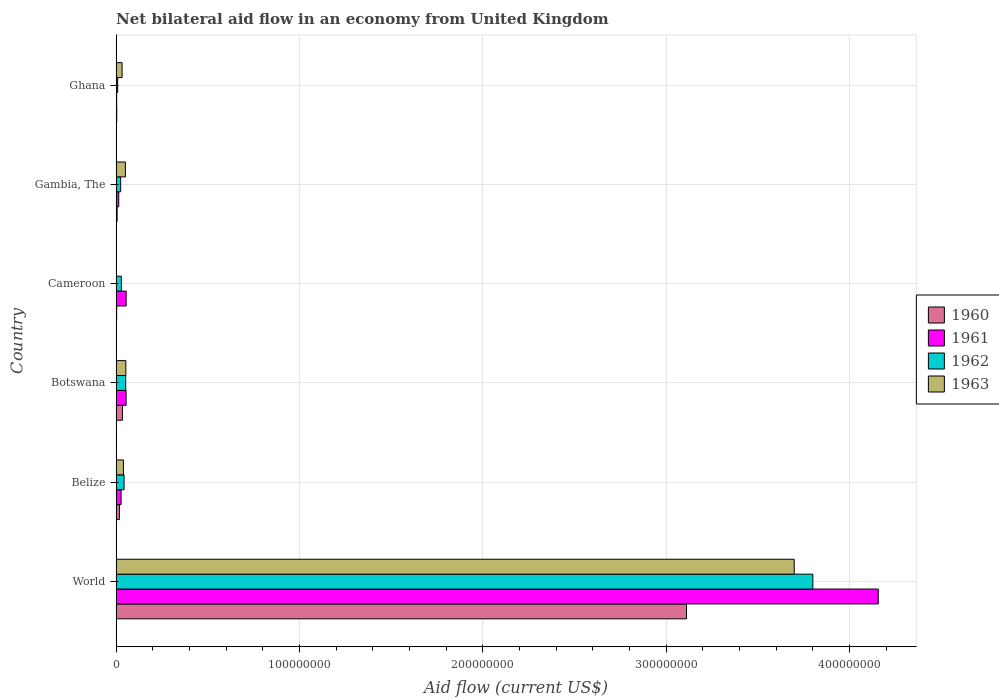How many different coloured bars are there?
Offer a very short reply. 4. How many groups of bars are there?
Your answer should be compact. 6. How many bars are there on the 2nd tick from the top?
Your answer should be very brief. 4. How many bars are there on the 3rd tick from the bottom?
Ensure brevity in your answer.  4. In how many cases, is the number of bars for a given country not equal to the number of legend labels?
Ensure brevity in your answer.  1. What is the net bilateral aid flow in 1963 in Belize?
Provide a short and direct response. 3.99e+06. Across all countries, what is the maximum net bilateral aid flow in 1963?
Your answer should be compact. 3.70e+08. What is the total net bilateral aid flow in 1962 in the graph?
Make the answer very short. 3.96e+08. What is the difference between the net bilateral aid flow in 1963 in Belize and that in Gambia, The?
Ensure brevity in your answer.  -1.07e+06. What is the difference between the net bilateral aid flow in 1962 in Ghana and the net bilateral aid flow in 1963 in World?
Give a very brief answer. -3.69e+08. What is the average net bilateral aid flow in 1962 per country?
Keep it short and to the point. 6.59e+07. What is the difference between the net bilateral aid flow in 1963 and net bilateral aid flow in 1960 in Belize?
Make the answer very short. 2.20e+06. In how many countries, is the net bilateral aid flow in 1962 greater than 220000000 US$?
Provide a succinct answer. 1. What is the ratio of the net bilateral aid flow in 1961 in Cameroon to that in World?
Ensure brevity in your answer.  0.01. Is the net bilateral aid flow in 1960 in Botswana less than that in Ghana?
Make the answer very short. No. Is the difference between the net bilateral aid flow in 1963 in Botswana and World greater than the difference between the net bilateral aid flow in 1960 in Botswana and World?
Ensure brevity in your answer.  No. What is the difference between the highest and the second highest net bilateral aid flow in 1961?
Provide a short and direct response. 4.10e+08. What is the difference between the highest and the lowest net bilateral aid flow in 1961?
Offer a very short reply. 4.15e+08. In how many countries, is the net bilateral aid flow in 1960 greater than the average net bilateral aid flow in 1960 taken over all countries?
Offer a very short reply. 1. Is it the case that in every country, the sum of the net bilateral aid flow in 1963 and net bilateral aid flow in 1961 is greater than the net bilateral aid flow in 1962?
Your answer should be compact. Yes. How many bars are there?
Offer a very short reply. 23. How many countries are there in the graph?
Your response must be concise. 6. Does the graph contain any zero values?
Your response must be concise. Yes. What is the title of the graph?
Give a very brief answer. Net bilateral aid flow in an economy from United Kingdom. Does "1978" appear as one of the legend labels in the graph?
Offer a very short reply. No. What is the label or title of the X-axis?
Your answer should be very brief. Aid flow (current US$). What is the Aid flow (current US$) in 1960 in World?
Offer a terse response. 3.11e+08. What is the Aid flow (current US$) in 1961 in World?
Ensure brevity in your answer.  4.16e+08. What is the Aid flow (current US$) of 1962 in World?
Your answer should be compact. 3.80e+08. What is the Aid flow (current US$) of 1963 in World?
Give a very brief answer. 3.70e+08. What is the Aid flow (current US$) of 1960 in Belize?
Ensure brevity in your answer.  1.79e+06. What is the Aid flow (current US$) of 1961 in Belize?
Ensure brevity in your answer.  2.70e+06. What is the Aid flow (current US$) of 1962 in Belize?
Make the answer very short. 4.33e+06. What is the Aid flow (current US$) of 1963 in Belize?
Make the answer very short. 3.99e+06. What is the Aid flow (current US$) of 1960 in Botswana?
Your answer should be compact. 3.43e+06. What is the Aid flow (current US$) of 1961 in Botswana?
Your response must be concise. 5.44e+06. What is the Aid flow (current US$) in 1962 in Botswana?
Ensure brevity in your answer.  5.22e+06. What is the Aid flow (current US$) in 1963 in Botswana?
Provide a short and direct response. 5.30e+06. What is the Aid flow (current US$) in 1960 in Cameroon?
Keep it short and to the point. 2.90e+05. What is the Aid flow (current US$) in 1961 in Cameroon?
Your response must be concise. 5.47e+06. What is the Aid flow (current US$) in 1962 in Cameroon?
Provide a succinct answer. 2.85e+06. What is the Aid flow (current US$) of 1963 in Cameroon?
Make the answer very short. 0. What is the Aid flow (current US$) in 1960 in Gambia, The?
Keep it short and to the point. 5.40e+05. What is the Aid flow (current US$) of 1961 in Gambia, The?
Make the answer very short. 1.43e+06. What is the Aid flow (current US$) in 1962 in Gambia, The?
Ensure brevity in your answer.  2.47e+06. What is the Aid flow (current US$) in 1963 in Gambia, The?
Keep it short and to the point. 5.06e+06. What is the Aid flow (current US$) of 1961 in Ghana?
Your answer should be very brief. 2.90e+05. What is the Aid flow (current US$) in 1962 in Ghana?
Make the answer very short. 8.30e+05. What is the Aid flow (current US$) in 1963 in Ghana?
Provide a short and direct response. 3.24e+06. Across all countries, what is the maximum Aid flow (current US$) in 1960?
Keep it short and to the point. 3.11e+08. Across all countries, what is the maximum Aid flow (current US$) in 1961?
Make the answer very short. 4.16e+08. Across all countries, what is the maximum Aid flow (current US$) of 1962?
Keep it short and to the point. 3.80e+08. Across all countries, what is the maximum Aid flow (current US$) of 1963?
Provide a succinct answer. 3.70e+08. Across all countries, what is the minimum Aid flow (current US$) in 1960?
Provide a short and direct response. 2.90e+05. Across all countries, what is the minimum Aid flow (current US$) of 1961?
Make the answer very short. 2.90e+05. Across all countries, what is the minimum Aid flow (current US$) in 1962?
Your answer should be very brief. 8.30e+05. Across all countries, what is the minimum Aid flow (current US$) of 1963?
Keep it short and to the point. 0. What is the total Aid flow (current US$) of 1960 in the graph?
Offer a terse response. 3.17e+08. What is the total Aid flow (current US$) of 1961 in the graph?
Make the answer very short. 4.31e+08. What is the total Aid flow (current US$) of 1962 in the graph?
Offer a very short reply. 3.96e+08. What is the total Aid flow (current US$) in 1963 in the graph?
Provide a short and direct response. 3.87e+08. What is the difference between the Aid flow (current US$) of 1960 in World and that in Belize?
Ensure brevity in your answer.  3.09e+08. What is the difference between the Aid flow (current US$) in 1961 in World and that in Belize?
Your answer should be compact. 4.13e+08. What is the difference between the Aid flow (current US$) in 1962 in World and that in Belize?
Give a very brief answer. 3.76e+08. What is the difference between the Aid flow (current US$) of 1963 in World and that in Belize?
Your answer should be compact. 3.66e+08. What is the difference between the Aid flow (current US$) in 1960 in World and that in Botswana?
Provide a short and direct response. 3.08e+08. What is the difference between the Aid flow (current US$) of 1961 in World and that in Botswana?
Provide a succinct answer. 4.10e+08. What is the difference between the Aid flow (current US$) in 1962 in World and that in Botswana?
Provide a short and direct response. 3.75e+08. What is the difference between the Aid flow (current US$) in 1963 in World and that in Botswana?
Provide a succinct answer. 3.65e+08. What is the difference between the Aid flow (current US$) of 1960 in World and that in Cameroon?
Offer a terse response. 3.11e+08. What is the difference between the Aid flow (current US$) in 1961 in World and that in Cameroon?
Provide a succinct answer. 4.10e+08. What is the difference between the Aid flow (current US$) of 1962 in World and that in Cameroon?
Ensure brevity in your answer.  3.77e+08. What is the difference between the Aid flow (current US$) in 1960 in World and that in Gambia, The?
Ensure brevity in your answer.  3.11e+08. What is the difference between the Aid flow (current US$) in 1961 in World and that in Gambia, The?
Your answer should be compact. 4.14e+08. What is the difference between the Aid flow (current US$) of 1962 in World and that in Gambia, The?
Offer a terse response. 3.78e+08. What is the difference between the Aid flow (current US$) in 1963 in World and that in Gambia, The?
Provide a succinct answer. 3.65e+08. What is the difference between the Aid flow (current US$) in 1960 in World and that in Ghana?
Your response must be concise. 3.11e+08. What is the difference between the Aid flow (current US$) of 1961 in World and that in Ghana?
Provide a short and direct response. 4.15e+08. What is the difference between the Aid flow (current US$) of 1962 in World and that in Ghana?
Your answer should be compact. 3.79e+08. What is the difference between the Aid flow (current US$) of 1963 in World and that in Ghana?
Your response must be concise. 3.67e+08. What is the difference between the Aid flow (current US$) of 1960 in Belize and that in Botswana?
Offer a terse response. -1.64e+06. What is the difference between the Aid flow (current US$) in 1961 in Belize and that in Botswana?
Your answer should be compact. -2.74e+06. What is the difference between the Aid flow (current US$) in 1962 in Belize and that in Botswana?
Ensure brevity in your answer.  -8.90e+05. What is the difference between the Aid flow (current US$) of 1963 in Belize and that in Botswana?
Make the answer very short. -1.31e+06. What is the difference between the Aid flow (current US$) in 1960 in Belize and that in Cameroon?
Make the answer very short. 1.50e+06. What is the difference between the Aid flow (current US$) of 1961 in Belize and that in Cameroon?
Your answer should be very brief. -2.77e+06. What is the difference between the Aid flow (current US$) of 1962 in Belize and that in Cameroon?
Keep it short and to the point. 1.48e+06. What is the difference between the Aid flow (current US$) in 1960 in Belize and that in Gambia, The?
Provide a succinct answer. 1.25e+06. What is the difference between the Aid flow (current US$) of 1961 in Belize and that in Gambia, The?
Offer a terse response. 1.27e+06. What is the difference between the Aid flow (current US$) in 1962 in Belize and that in Gambia, The?
Your response must be concise. 1.86e+06. What is the difference between the Aid flow (current US$) of 1963 in Belize and that in Gambia, The?
Make the answer very short. -1.07e+06. What is the difference between the Aid flow (current US$) in 1960 in Belize and that in Ghana?
Provide a short and direct response. 1.45e+06. What is the difference between the Aid flow (current US$) in 1961 in Belize and that in Ghana?
Make the answer very short. 2.41e+06. What is the difference between the Aid flow (current US$) of 1962 in Belize and that in Ghana?
Your answer should be very brief. 3.50e+06. What is the difference between the Aid flow (current US$) of 1963 in Belize and that in Ghana?
Offer a terse response. 7.50e+05. What is the difference between the Aid flow (current US$) in 1960 in Botswana and that in Cameroon?
Your response must be concise. 3.14e+06. What is the difference between the Aid flow (current US$) in 1962 in Botswana and that in Cameroon?
Your answer should be very brief. 2.37e+06. What is the difference between the Aid flow (current US$) of 1960 in Botswana and that in Gambia, The?
Your answer should be compact. 2.89e+06. What is the difference between the Aid flow (current US$) of 1961 in Botswana and that in Gambia, The?
Provide a succinct answer. 4.01e+06. What is the difference between the Aid flow (current US$) in 1962 in Botswana and that in Gambia, The?
Offer a very short reply. 2.75e+06. What is the difference between the Aid flow (current US$) in 1963 in Botswana and that in Gambia, The?
Ensure brevity in your answer.  2.40e+05. What is the difference between the Aid flow (current US$) in 1960 in Botswana and that in Ghana?
Offer a terse response. 3.09e+06. What is the difference between the Aid flow (current US$) of 1961 in Botswana and that in Ghana?
Provide a short and direct response. 5.15e+06. What is the difference between the Aid flow (current US$) in 1962 in Botswana and that in Ghana?
Your answer should be very brief. 4.39e+06. What is the difference between the Aid flow (current US$) of 1963 in Botswana and that in Ghana?
Keep it short and to the point. 2.06e+06. What is the difference between the Aid flow (current US$) of 1960 in Cameroon and that in Gambia, The?
Make the answer very short. -2.50e+05. What is the difference between the Aid flow (current US$) in 1961 in Cameroon and that in Gambia, The?
Provide a short and direct response. 4.04e+06. What is the difference between the Aid flow (current US$) of 1961 in Cameroon and that in Ghana?
Your answer should be compact. 5.18e+06. What is the difference between the Aid flow (current US$) of 1962 in Cameroon and that in Ghana?
Give a very brief answer. 2.02e+06. What is the difference between the Aid flow (current US$) in 1960 in Gambia, The and that in Ghana?
Give a very brief answer. 2.00e+05. What is the difference between the Aid flow (current US$) of 1961 in Gambia, The and that in Ghana?
Provide a short and direct response. 1.14e+06. What is the difference between the Aid flow (current US$) in 1962 in Gambia, The and that in Ghana?
Provide a succinct answer. 1.64e+06. What is the difference between the Aid flow (current US$) in 1963 in Gambia, The and that in Ghana?
Provide a short and direct response. 1.82e+06. What is the difference between the Aid flow (current US$) of 1960 in World and the Aid flow (current US$) of 1961 in Belize?
Offer a very short reply. 3.08e+08. What is the difference between the Aid flow (current US$) of 1960 in World and the Aid flow (current US$) of 1962 in Belize?
Offer a very short reply. 3.07e+08. What is the difference between the Aid flow (current US$) in 1960 in World and the Aid flow (current US$) in 1963 in Belize?
Your response must be concise. 3.07e+08. What is the difference between the Aid flow (current US$) in 1961 in World and the Aid flow (current US$) in 1962 in Belize?
Offer a terse response. 4.11e+08. What is the difference between the Aid flow (current US$) in 1961 in World and the Aid flow (current US$) in 1963 in Belize?
Offer a terse response. 4.12e+08. What is the difference between the Aid flow (current US$) of 1962 in World and the Aid flow (current US$) of 1963 in Belize?
Provide a succinct answer. 3.76e+08. What is the difference between the Aid flow (current US$) in 1960 in World and the Aid flow (current US$) in 1961 in Botswana?
Give a very brief answer. 3.06e+08. What is the difference between the Aid flow (current US$) of 1960 in World and the Aid flow (current US$) of 1962 in Botswana?
Make the answer very short. 3.06e+08. What is the difference between the Aid flow (current US$) in 1960 in World and the Aid flow (current US$) in 1963 in Botswana?
Keep it short and to the point. 3.06e+08. What is the difference between the Aid flow (current US$) in 1961 in World and the Aid flow (current US$) in 1962 in Botswana?
Keep it short and to the point. 4.10e+08. What is the difference between the Aid flow (current US$) of 1961 in World and the Aid flow (current US$) of 1963 in Botswana?
Make the answer very short. 4.10e+08. What is the difference between the Aid flow (current US$) of 1962 in World and the Aid flow (current US$) of 1963 in Botswana?
Your answer should be compact. 3.75e+08. What is the difference between the Aid flow (current US$) in 1960 in World and the Aid flow (current US$) in 1961 in Cameroon?
Give a very brief answer. 3.06e+08. What is the difference between the Aid flow (current US$) of 1960 in World and the Aid flow (current US$) of 1962 in Cameroon?
Ensure brevity in your answer.  3.08e+08. What is the difference between the Aid flow (current US$) of 1961 in World and the Aid flow (current US$) of 1962 in Cameroon?
Give a very brief answer. 4.13e+08. What is the difference between the Aid flow (current US$) in 1960 in World and the Aid flow (current US$) in 1961 in Gambia, The?
Provide a succinct answer. 3.10e+08. What is the difference between the Aid flow (current US$) in 1960 in World and the Aid flow (current US$) in 1962 in Gambia, The?
Make the answer very short. 3.09e+08. What is the difference between the Aid flow (current US$) of 1960 in World and the Aid flow (current US$) of 1963 in Gambia, The?
Ensure brevity in your answer.  3.06e+08. What is the difference between the Aid flow (current US$) of 1961 in World and the Aid flow (current US$) of 1962 in Gambia, The?
Offer a terse response. 4.13e+08. What is the difference between the Aid flow (current US$) of 1961 in World and the Aid flow (current US$) of 1963 in Gambia, The?
Your response must be concise. 4.11e+08. What is the difference between the Aid flow (current US$) in 1962 in World and the Aid flow (current US$) in 1963 in Gambia, The?
Give a very brief answer. 3.75e+08. What is the difference between the Aid flow (current US$) of 1960 in World and the Aid flow (current US$) of 1961 in Ghana?
Make the answer very short. 3.11e+08. What is the difference between the Aid flow (current US$) in 1960 in World and the Aid flow (current US$) in 1962 in Ghana?
Ensure brevity in your answer.  3.10e+08. What is the difference between the Aid flow (current US$) of 1960 in World and the Aid flow (current US$) of 1963 in Ghana?
Keep it short and to the point. 3.08e+08. What is the difference between the Aid flow (current US$) in 1961 in World and the Aid flow (current US$) in 1962 in Ghana?
Ensure brevity in your answer.  4.15e+08. What is the difference between the Aid flow (current US$) of 1961 in World and the Aid flow (current US$) of 1963 in Ghana?
Offer a terse response. 4.12e+08. What is the difference between the Aid flow (current US$) in 1962 in World and the Aid flow (current US$) in 1963 in Ghana?
Your answer should be very brief. 3.77e+08. What is the difference between the Aid flow (current US$) of 1960 in Belize and the Aid flow (current US$) of 1961 in Botswana?
Your answer should be very brief. -3.65e+06. What is the difference between the Aid flow (current US$) in 1960 in Belize and the Aid flow (current US$) in 1962 in Botswana?
Provide a short and direct response. -3.43e+06. What is the difference between the Aid flow (current US$) in 1960 in Belize and the Aid flow (current US$) in 1963 in Botswana?
Your answer should be very brief. -3.51e+06. What is the difference between the Aid flow (current US$) of 1961 in Belize and the Aid flow (current US$) of 1962 in Botswana?
Provide a succinct answer. -2.52e+06. What is the difference between the Aid flow (current US$) of 1961 in Belize and the Aid flow (current US$) of 1963 in Botswana?
Provide a short and direct response. -2.60e+06. What is the difference between the Aid flow (current US$) in 1962 in Belize and the Aid flow (current US$) in 1963 in Botswana?
Offer a terse response. -9.70e+05. What is the difference between the Aid flow (current US$) of 1960 in Belize and the Aid flow (current US$) of 1961 in Cameroon?
Give a very brief answer. -3.68e+06. What is the difference between the Aid flow (current US$) of 1960 in Belize and the Aid flow (current US$) of 1962 in Cameroon?
Your answer should be compact. -1.06e+06. What is the difference between the Aid flow (current US$) in 1961 in Belize and the Aid flow (current US$) in 1962 in Cameroon?
Keep it short and to the point. -1.50e+05. What is the difference between the Aid flow (current US$) in 1960 in Belize and the Aid flow (current US$) in 1962 in Gambia, The?
Your answer should be compact. -6.80e+05. What is the difference between the Aid flow (current US$) in 1960 in Belize and the Aid flow (current US$) in 1963 in Gambia, The?
Provide a succinct answer. -3.27e+06. What is the difference between the Aid flow (current US$) of 1961 in Belize and the Aid flow (current US$) of 1962 in Gambia, The?
Keep it short and to the point. 2.30e+05. What is the difference between the Aid flow (current US$) in 1961 in Belize and the Aid flow (current US$) in 1963 in Gambia, The?
Provide a succinct answer. -2.36e+06. What is the difference between the Aid flow (current US$) of 1962 in Belize and the Aid flow (current US$) of 1963 in Gambia, The?
Ensure brevity in your answer.  -7.30e+05. What is the difference between the Aid flow (current US$) in 1960 in Belize and the Aid flow (current US$) in 1961 in Ghana?
Your answer should be very brief. 1.50e+06. What is the difference between the Aid flow (current US$) of 1960 in Belize and the Aid flow (current US$) of 1962 in Ghana?
Make the answer very short. 9.60e+05. What is the difference between the Aid flow (current US$) in 1960 in Belize and the Aid flow (current US$) in 1963 in Ghana?
Give a very brief answer. -1.45e+06. What is the difference between the Aid flow (current US$) of 1961 in Belize and the Aid flow (current US$) of 1962 in Ghana?
Ensure brevity in your answer.  1.87e+06. What is the difference between the Aid flow (current US$) in 1961 in Belize and the Aid flow (current US$) in 1963 in Ghana?
Make the answer very short. -5.40e+05. What is the difference between the Aid flow (current US$) of 1962 in Belize and the Aid flow (current US$) of 1963 in Ghana?
Make the answer very short. 1.09e+06. What is the difference between the Aid flow (current US$) in 1960 in Botswana and the Aid flow (current US$) in 1961 in Cameroon?
Your answer should be compact. -2.04e+06. What is the difference between the Aid flow (current US$) of 1960 in Botswana and the Aid flow (current US$) of 1962 in Cameroon?
Provide a short and direct response. 5.80e+05. What is the difference between the Aid flow (current US$) in 1961 in Botswana and the Aid flow (current US$) in 1962 in Cameroon?
Your response must be concise. 2.59e+06. What is the difference between the Aid flow (current US$) in 1960 in Botswana and the Aid flow (current US$) in 1961 in Gambia, The?
Make the answer very short. 2.00e+06. What is the difference between the Aid flow (current US$) in 1960 in Botswana and the Aid flow (current US$) in 1962 in Gambia, The?
Give a very brief answer. 9.60e+05. What is the difference between the Aid flow (current US$) of 1960 in Botswana and the Aid flow (current US$) of 1963 in Gambia, The?
Your answer should be compact. -1.63e+06. What is the difference between the Aid flow (current US$) in 1961 in Botswana and the Aid flow (current US$) in 1962 in Gambia, The?
Make the answer very short. 2.97e+06. What is the difference between the Aid flow (current US$) of 1960 in Botswana and the Aid flow (current US$) of 1961 in Ghana?
Your response must be concise. 3.14e+06. What is the difference between the Aid flow (current US$) in 1960 in Botswana and the Aid flow (current US$) in 1962 in Ghana?
Provide a succinct answer. 2.60e+06. What is the difference between the Aid flow (current US$) in 1960 in Botswana and the Aid flow (current US$) in 1963 in Ghana?
Keep it short and to the point. 1.90e+05. What is the difference between the Aid flow (current US$) in 1961 in Botswana and the Aid flow (current US$) in 1962 in Ghana?
Offer a terse response. 4.61e+06. What is the difference between the Aid flow (current US$) in 1961 in Botswana and the Aid flow (current US$) in 1963 in Ghana?
Offer a terse response. 2.20e+06. What is the difference between the Aid flow (current US$) in 1962 in Botswana and the Aid flow (current US$) in 1963 in Ghana?
Give a very brief answer. 1.98e+06. What is the difference between the Aid flow (current US$) of 1960 in Cameroon and the Aid flow (current US$) of 1961 in Gambia, The?
Ensure brevity in your answer.  -1.14e+06. What is the difference between the Aid flow (current US$) in 1960 in Cameroon and the Aid flow (current US$) in 1962 in Gambia, The?
Ensure brevity in your answer.  -2.18e+06. What is the difference between the Aid flow (current US$) of 1960 in Cameroon and the Aid flow (current US$) of 1963 in Gambia, The?
Keep it short and to the point. -4.77e+06. What is the difference between the Aid flow (current US$) of 1961 in Cameroon and the Aid flow (current US$) of 1963 in Gambia, The?
Your response must be concise. 4.10e+05. What is the difference between the Aid flow (current US$) in 1962 in Cameroon and the Aid flow (current US$) in 1963 in Gambia, The?
Your answer should be compact. -2.21e+06. What is the difference between the Aid flow (current US$) in 1960 in Cameroon and the Aid flow (current US$) in 1962 in Ghana?
Ensure brevity in your answer.  -5.40e+05. What is the difference between the Aid flow (current US$) of 1960 in Cameroon and the Aid flow (current US$) of 1963 in Ghana?
Offer a terse response. -2.95e+06. What is the difference between the Aid flow (current US$) in 1961 in Cameroon and the Aid flow (current US$) in 1962 in Ghana?
Keep it short and to the point. 4.64e+06. What is the difference between the Aid flow (current US$) of 1961 in Cameroon and the Aid flow (current US$) of 1963 in Ghana?
Provide a short and direct response. 2.23e+06. What is the difference between the Aid flow (current US$) in 1962 in Cameroon and the Aid flow (current US$) in 1963 in Ghana?
Provide a succinct answer. -3.90e+05. What is the difference between the Aid flow (current US$) of 1960 in Gambia, The and the Aid flow (current US$) of 1962 in Ghana?
Make the answer very short. -2.90e+05. What is the difference between the Aid flow (current US$) of 1960 in Gambia, The and the Aid flow (current US$) of 1963 in Ghana?
Ensure brevity in your answer.  -2.70e+06. What is the difference between the Aid flow (current US$) in 1961 in Gambia, The and the Aid flow (current US$) in 1963 in Ghana?
Give a very brief answer. -1.81e+06. What is the difference between the Aid flow (current US$) in 1962 in Gambia, The and the Aid flow (current US$) in 1963 in Ghana?
Keep it short and to the point. -7.70e+05. What is the average Aid flow (current US$) in 1960 per country?
Provide a succinct answer. 5.29e+07. What is the average Aid flow (current US$) of 1961 per country?
Keep it short and to the point. 7.18e+07. What is the average Aid flow (current US$) in 1962 per country?
Your answer should be compact. 6.59e+07. What is the average Aid flow (current US$) of 1963 per country?
Offer a very short reply. 6.46e+07. What is the difference between the Aid flow (current US$) of 1960 and Aid flow (current US$) of 1961 in World?
Your response must be concise. -1.05e+08. What is the difference between the Aid flow (current US$) in 1960 and Aid flow (current US$) in 1962 in World?
Provide a short and direct response. -6.89e+07. What is the difference between the Aid flow (current US$) in 1960 and Aid flow (current US$) in 1963 in World?
Your answer should be very brief. -5.88e+07. What is the difference between the Aid flow (current US$) of 1961 and Aid flow (current US$) of 1962 in World?
Your answer should be very brief. 3.57e+07. What is the difference between the Aid flow (current US$) in 1961 and Aid flow (current US$) in 1963 in World?
Offer a very short reply. 4.58e+07. What is the difference between the Aid flow (current US$) in 1962 and Aid flow (current US$) in 1963 in World?
Provide a short and direct response. 1.02e+07. What is the difference between the Aid flow (current US$) of 1960 and Aid flow (current US$) of 1961 in Belize?
Your answer should be very brief. -9.10e+05. What is the difference between the Aid flow (current US$) in 1960 and Aid flow (current US$) in 1962 in Belize?
Your response must be concise. -2.54e+06. What is the difference between the Aid flow (current US$) in 1960 and Aid flow (current US$) in 1963 in Belize?
Make the answer very short. -2.20e+06. What is the difference between the Aid flow (current US$) of 1961 and Aid flow (current US$) of 1962 in Belize?
Ensure brevity in your answer.  -1.63e+06. What is the difference between the Aid flow (current US$) of 1961 and Aid flow (current US$) of 1963 in Belize?
Give a very brief answer. -1.29e+06. What is the difference between the Aid flow (current US$) of 1962 and Aid flow (current US$) of 1963 in Belize?
Your response must be concise. 3.40e+05. What is the difference between the Aid flow (current US$) in 1960 and Aid flow (current US$) in 1961 in Botswana?
Give a very brief answer. -2.01e+06. What is the difference between the Aid flow (current US$) of 1960 and Aid flow (current US$) of 1962 in Botswana?
Offer a very short reply. -1.79e+06. What is the difference between the Aid flow (current US$) of 1960 and Aid flow (current US$) of 1963 in Botswana?
Your answer should be very brief. -1.87e+06. What is the difference between the Aid flow (current US$) of 1961 and Aid flow (current US$) of 1962 in Botswana?
Your response must be concise. 2.20e+05. What is the difference between the Aid flow (current US$) in 1960 and Aid flow (current US$) in 1961 in Cameroon?
Offer a terse response. -5.18e+06. What is the difference between the Aid flow (current US$) in 1960 and Aid flow (current US$) in 1962 in Cameroon?
Ensure brevity in your answer.  -2.56e+06. What is the difference between the Aid flow (current US$) of 1961 and Aid flow (current US$) of 1962 in Cameroon?
Offer a terse response. 2.62e+06. What is the difference between the Aid flow (current US$) in 1960 and Aid flow (current US$) in 1961 in Gambia, The?
Offer a terse response. -8.90e+05. What is the difference between the Aid flow (current US$) of 1960 and Aid flow (current US$) of 1962 in Gambia, The?
Provide a succinct answer. -1.93e+06. What is the difference between the Aid flow (current US$) in 1960 and Aid flow (current US$) in 1963 in Gambia, The?
Offer a very short reply. -4.52e+06. What is the difference between the Aid flow (current US$) in 1961 and Aid flow (current US$) in 1962 in Gambia, The?
Give a very brief answer. -1.04e+06. What is the difference between the Aid flow (current US$) of 1961 and Aid flow (current US$) of 1963 in Gambia, The?
Give a very brief answer. -3.63e+06. What is the difference between the Aid flow (current US$) in 1962 and Aid flow (current US$) in 1963 in Gambia, The?
Ensure brevity in your answer.  -2.59e+06. What is the difference between the Aid flow (current US$) of 1960 and Aid flow (current US$) of 1961 in Ghana?
Your answer should be compact. 5.00e+04. What is the difference between the Aid flow (current US$) in 1960 and Aid flow (current US$) in 1962 in Ghana?
Your answer should be very brief. -4.90e+05. What is the difference between the Aid flow (current US$) of 1960 and Aid flow (current US$) of 1963 in Ghana?
Make the answer very short. -2.90e+06. What is the difference between the Aid flow (current US$) in 1961 and Aid flow (current US$) in 1962 in Ghana?
Offer a terse response. -5.40e+05. What is the difference between the Aid flow (current US$) of 1961 and Aid flow (current US$) of 1963 in Ghana?
Keep it short and to the point. -2.95e+06. What is the difference between the Aid flow (current US$) of 1962 and Aid flow (current US$) of 1963 in Ghana?
Give a very brief answer. -2.41e+06. What is the ratio of the Aid flow (current US$) of 1960 in World to that in Belize?
Give a very brief answer. 173.77. What is the ratio of the Aid flow (current US$) of 1961 in World to that in Belize?
Offer a terse response. 153.94. What is the ratio of the Aid flow (current US$) in 1962 in World to that in Belize?
Provide a short and direct response. 87.75. What is the ratio of the Aid flow (current US$) of 1963 in World to that in Belize?
Your response must be concise. 92.68. What is the ratio of the Aid flow (current US$) in 1960 in World to that in Botswana?
Your answer should be compact. 90.69. What is the ratio of the Aid flow (current US$) of 1961 in World to that in Botswana?
Provide a succinct answer. 76.4. What is the ratio of the Aid flow (current US$) in 1962 in World to that in Botswana?
Provide a short and direct response. 72.79. What is the ratio of the Aid flow (current US$) in 1963 in World to that in Botswana?
Provide a short and direct response. 69.78. What is the ratio of the Aid flow (current US$) in 1960 in World to that in Cameroon?
Ensure brevity in your answer.  1072.59. What is the ratio of the Aid flow (current US$) in 1961 in World to that in Cameroon?
Your answer should be very brief. 75.99. What is the ratio of the Aid flow (current US$) in 1962 in World to that in Cameroon?
Provide a succinct answer. 133.32. What is the ratio of the Aid flow (current US$) of 1960 in World to that in Gambia, The?
Offer a very short reply. 576.02. What is the ratio of the Aid flow (current US$) of 1961 in World to that in Gambia, The?
Make the answer very short. 290.66. What is the ratio of the Aid flow (current US$) of 1962 in World to that in Gambia, The?
Offer a terse response. 153.83. What is the ratio of the Aid flow (current US$) of 1963 in World to that in Gambia, The?
Keep it short and to the point. 73.08. What is the ratio of the Aid flow (current US$) in 1960 in World to that in Ghana?
Offer a very short reply. 914.85. What is the ratio of the Aid flow (current US$) of 1961 in World to that in Ghana?
Offer a very short reply. 1433.24. What is the ratio of the Aid flow (current US$) in 1962 in World to that in Ghana?
Offer a very short reply. 457.8. What is the ratio of the Aid flow (current US$) in 1963 in World to that in Ghana?
Offer a very short reply. 114.14. What is the ratio of the Aid flow (current US$) of 1960 in Belize to that in Botswana?
Your answer should be compact. 0.52. What is the ratio of the Aid flow (current US$) of 1961 in Belize to that in Botswana?
Keep it short and to the point. 0.5. What is the ratio of the Aid flow (current US$) in 1962 in Belize to that in Botswana?
Give a very brief answer. 0.83. What is the ratio of the Aid flow (current US$) in 1963 in Belize to that in Botswana?
Make the answer very short. 0.75. What is the ratio of the Aid flow (current US$) in 1960 in Belize to that in Cameroon?
Keep it short and to the point. 6.17. What is the ratio of the Aid flow (current US$) in 1961 in Belize to that in Cameroon?
Provide a succinct answer. 0.49. What is the ratio of the Aid flow (current US$) in 1962 in Belize to that in Cameroon?
Ensure brevity in your answer.  1.52. What is the ratio of the Aid flow (current US$) in 1960 in Belize to that in Gambia, The?
Offer a terse response. 3.31. What is the ratio of the Aid flow (current US$) in 1961 in Belize to that in Gambia, The?
Offer a very short reply. 1.89. What is the ratio of the Aid flow (current US$) in 1962 in Belize to that in Gambia, The?
Provide a short and direct response. 1.75. What is the ratio of the Aid flow (current US$) in 1963 in Belize to that in Gambia, The?
Ensure brevity in your answer.  0.79. What is the ratio of the Aid flow (current US$) in 1960 in Belize to that in Ghana?
Your answer should be compact. 5.26. What is the ratio of the Aid flow (current US$) of 1961 in Belize to that in Ghana?
Keep it short and to the point. 9.31. What is the ratio of the Aid flow (current US$) in 1962 in Belize to that in Ghana?
Give a very brief answer. 5.22. What is the ratio of the Aid flow (current US$) of 1963 in Belize to that in Ghana?
Your answer should be very brief. 1.23. What is the ratio of the Aid flow (current US$) in 1960 in Botswana to that in Cameroon?
Your answer should be very brief. 11.83. What is the ratio of the Aid flow (current US$) of 1961 in Botswana to that in Cameroon?
Make the answer very short. 0.99. What is the ratio of the Aid flow (current US$) in 1962 in Botswana to that in Cameroon?
Provide a succinct answer. 1.83. What is the ratio of the Aid flow (current US$) in 1960 in Botswana to that in Gambia, The?
Offer a very short reply. 6.35. What is the ratio of the Aid flow (current US$) in 1961 in Botswana to that in Gambia, The?
Provide a short and direct response. 3.8. What is the ratio of the Aid flow (current US$) of 1962 in Botswana to that in Gambia, The?
Keep it short and to the point. 2.11. What is the ratio of the Aid flow (current US$) of 1963 in Botswana to that in Gambia, The?
Your answer should be compact. 1.05. What is the ratio of the Aid flow (current US$) in 1960 in Botswana to that in Ghana?
Your response must be concise. 10.09. What is the ratio of the Aid flow (current US$) in 1961 in Botswana to that in Ghana?
Provide a short and direct response. 18.76. What is the ratio of the Aid flow (current US$) of 1962 in Botswana to that in Ghana?
Provide a short and direct response. 6.29. What is the ratio of the Aid flow (current US$) of 1963 in Botswana to that in Ghana?
Keep it short and to the point. 1.64. What is the ratio of the Aid flow (current US$) in 1960 in Cameroon to that in Gambia, The?
Offer a very short reply. 0.54. What is the ratio of the Aid flow (current US$) of 1961 in Cameroon to that in Gambia, The?
Offer a very short reply. 3.83. What is the ratio of the Aid flow (current US$) in 1962 in Cameroon to that in Gambia, The?
Your response must be concise. 1.15. What is the ratio of the Aid flow (current US$) in 1960 in Cameroon to that in Ghana?
Make the answer very short. 0.85. What is the ratio of the Aid flow (current US$) of 1961 in Cameroon to that in Ghana?
Provide a short and direct response. 18.86. What is the ratio of the Aid flow (current US$) in 1962 in Cameroon to that in Ghana?
Ensure brevity in your answer.  3.43. What is the ratio of the Aid flow (current US$) of 1960 in Gambia, The to that in Ghana?
Provide a succinct answer. 1.59. What is the ratio of the Aid flow (current US$) of 1961 in Gambia, The to that in Ghana?
Make the answer very short. 4.93. What is the ratio of the Aid flow (current US$) in 1962 in Gambia, The to that in Ghana?
Keep it short and to the point. 2.98. What is the ratio of the Aid flow (current US$) in 1963 in Gambia, The to that in Ghana?
Provide a short and direct response. 1.56. What is the difference between the highest and the second highest Aid flow (current US$) of 1960?
Your answer should be very brief. 3.08e+08. What is the difference between the highest and the second highest Aid flow (current US$) of 1961?
Give a very brief answer. 4.10e+08. What is the difference between the highest and the second highest Aid flow (current US$) of 1962?
Keep it short and to the point. 3.75e+08. What is the difference between the highest and the second highest Aid flow (current US$) of 1963?
Ensure brevity in your answer.  3.65e+08. What is the difference between the highest and the lowest Aid flow (current US$) of 1960?
Your answer should be compact. 3.11e+08. What is the difference between the highest and the lowest Aid flow (current US$) of 1961?
Your answer should be compact. 4.15e+08. What is the difference between the highest and the lowest Aid flow (current US$) in 1962?
Your answer should be compact. 3.79e+08. What is the difference between the highest and the lowest Aid flow (current US$) of 1963?
Offer a terse response. 3.70e+08. 